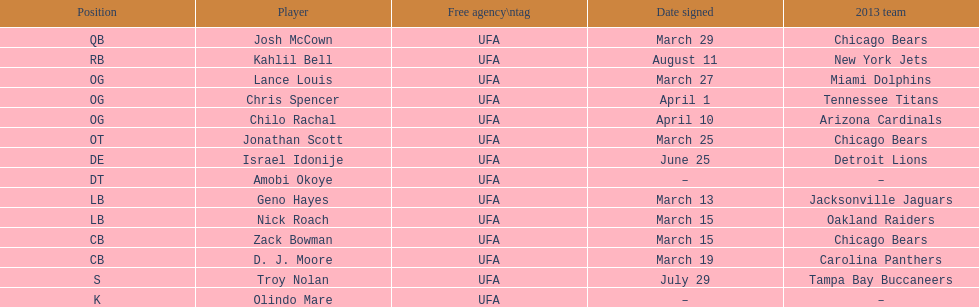What is the sum of all 2013 teams listed on the chart? 10. 